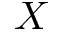Convert formula to latex. <formula><loc_0><loc_0><loc_500><loc_500>X</formula> 